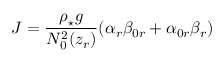Convert formula to latex. <formula><loc_0><loc_0><loc_500><loc_500>J = \frac { \rho _ { ^ { * } } g } { N _ { 0 } ^ { 2 } ( z _ { r } ) } ( \alpha _ { r } \beta _ { 0 r } + \alpha _ { 0 r } \beta _ { r } )</formula> 